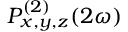<formula> <loc_0><loc_0><loc_500><loc_500>P _ { x , y , z } ^ { ( 2 ) } ( 2 \omega )</formula> 